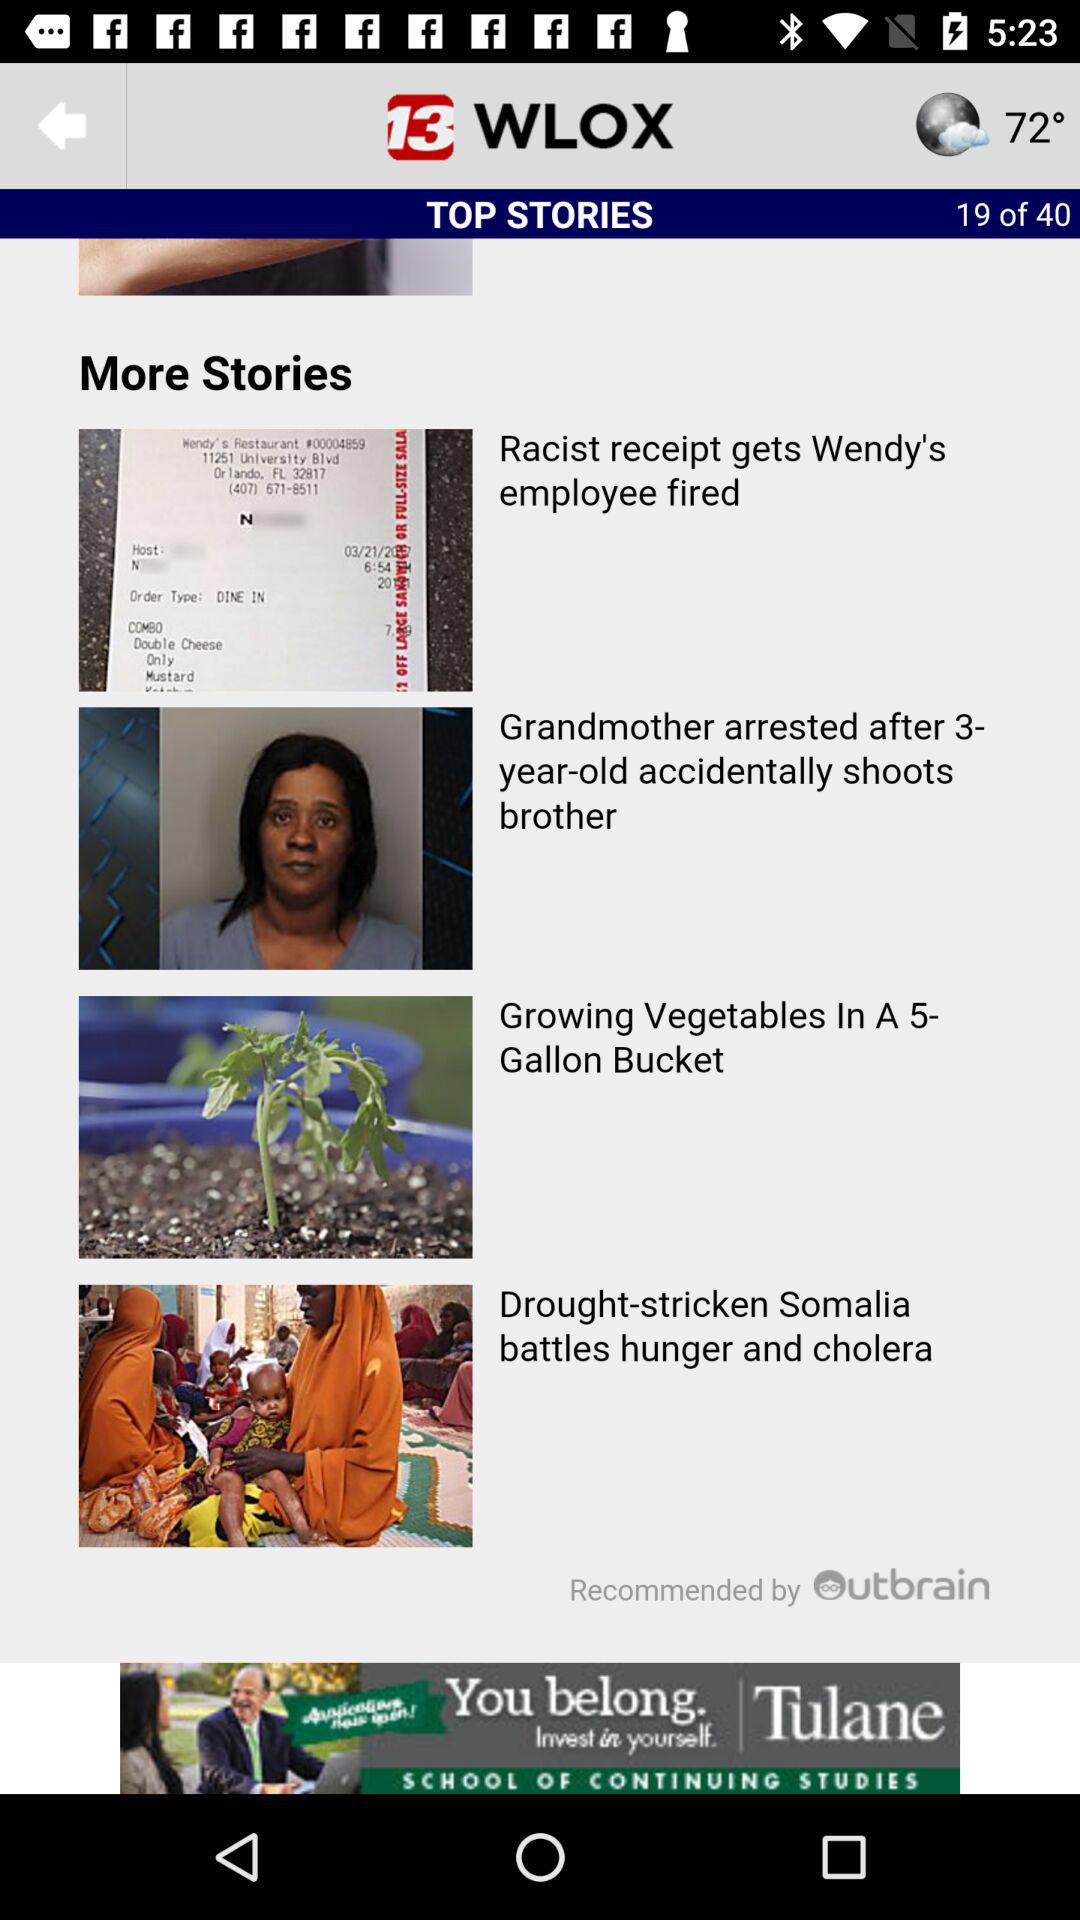What is the temperature that shows? The temperature is 72°. 